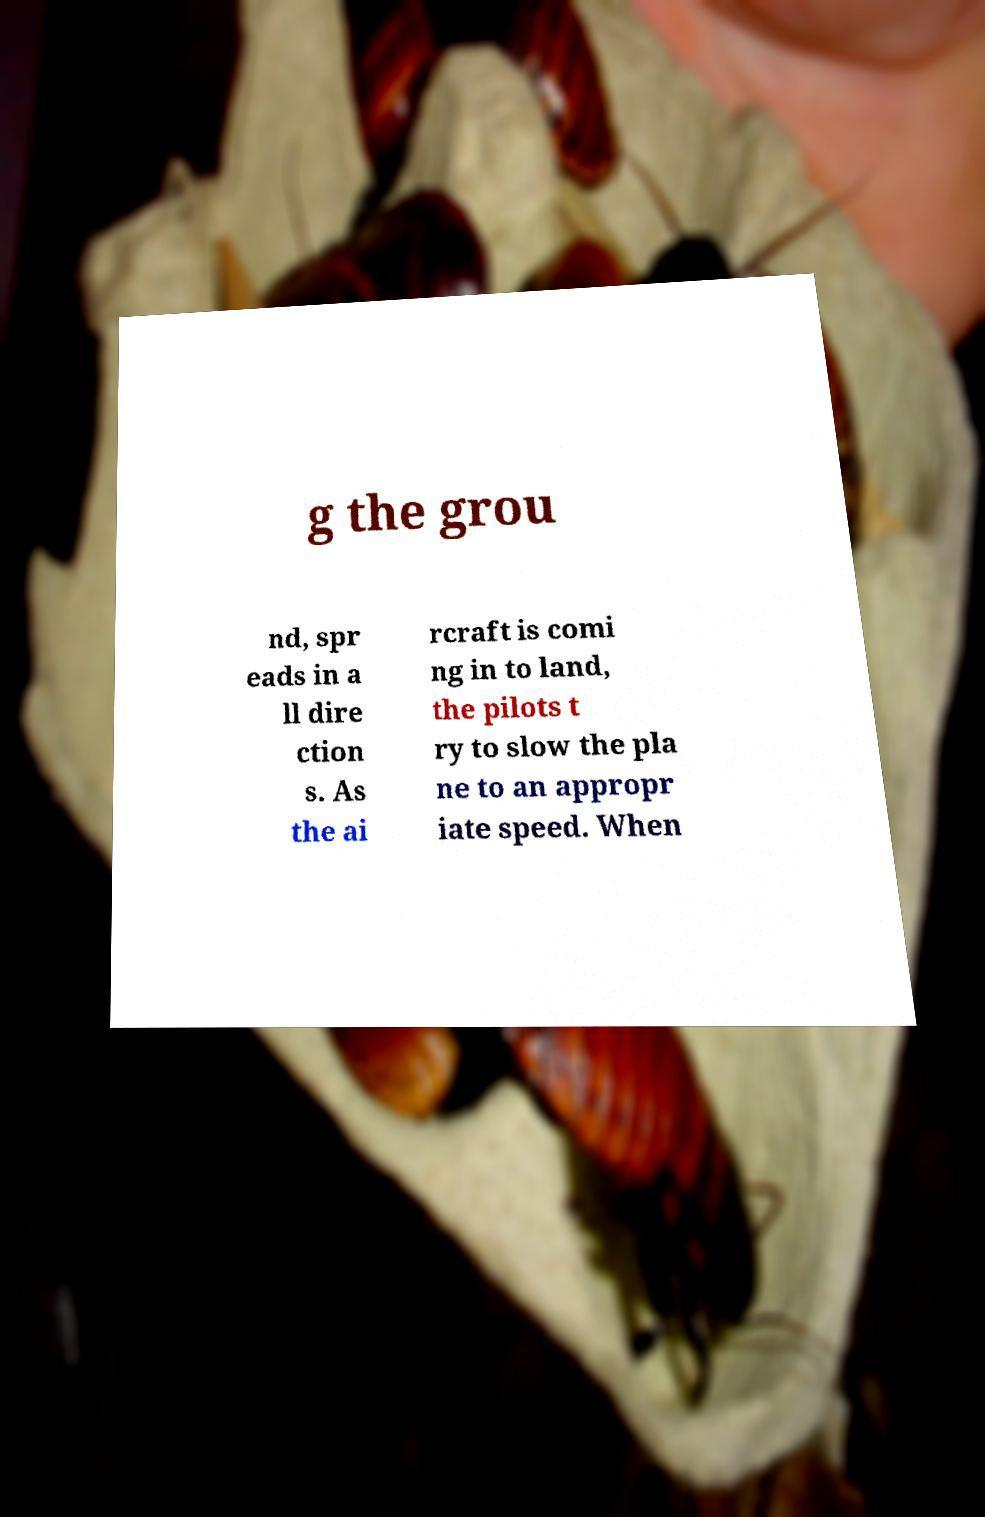Please identify and transcribe the text found in this image. g the grou nd, spr eads in a ll dire ction s. As the ai rcraft is comi ng in to land, the pilots t ry to slow the pla ne to an appropr iate speed. When 